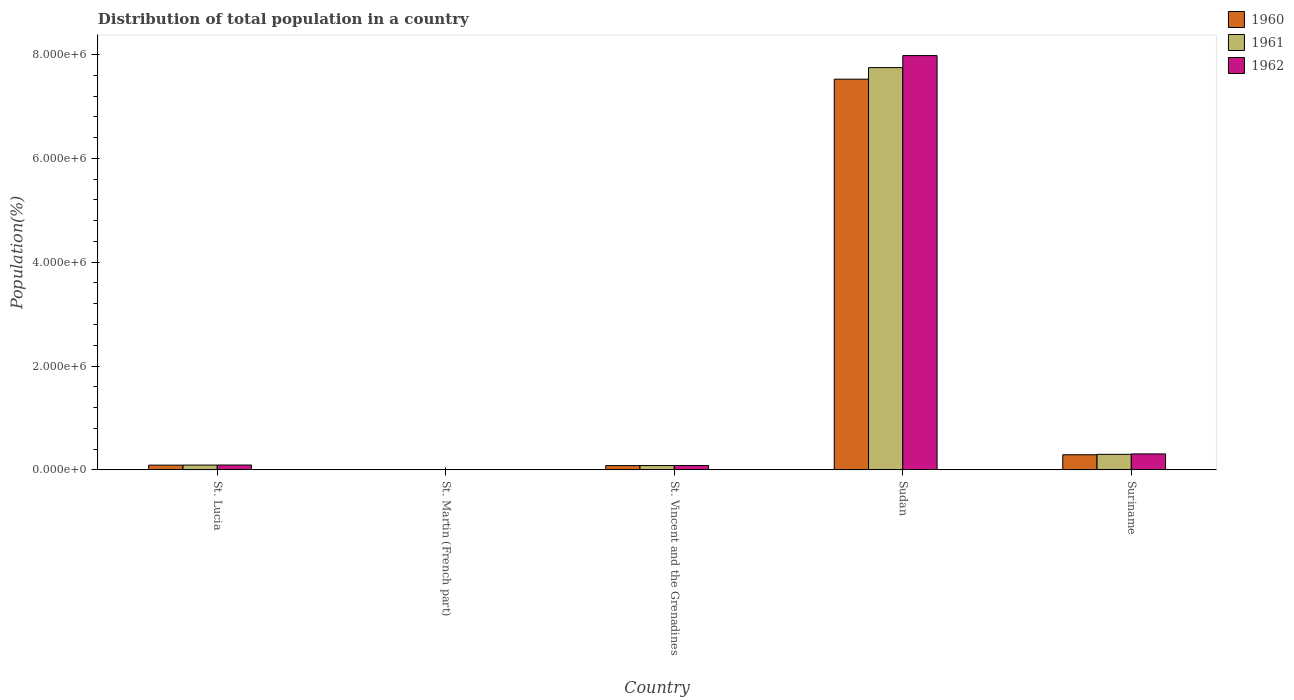How many different coloured bars are there?
Offer a very short reply. 3. How many groups of bars are there?
Offer a very short reply. 5. Are the number of bars on each tick of the X-axis equal?
Offer a very short reply. Yes. What is the label of the 2nd group of bars from the left?
Keep it short and to the point. St. Martin (French part). What is the population of in 1962 in Sudan?
Provide a succinct answer. 7.98e+06. Across all countries, what is the maximum population of in 1961?
Provide a short and direct response. 7.75e+06. Across all countries, what is the minimum population of in 1962?
Keep it short and to the point. 4566. In which country was the population of in 1961 maximum?
Your answer should be very brief. Sudan. In which country was the population of in 1960 minimum?
Offer a very short reply. St. Martin (French part). What is the total population of in 1962 in the graph?
Provide a short and direct response. 8.47e+06. What is the difference between the population of in 1960 in St. Martin (French part) and that in Suriname?
Ensure brevity in your answer.  -2.86e+05. What is the difference between the population of in 1961 in St. Lucia and the population of in 1960 in Sudan?
Make the answer very short. -7.44e+06. What is the average population of in 1962 per country?
Ensure brevity in your answer.  1.69e+06. What is the difference between the population of of/in 1960 and population of of/in 1962 in Suriname?
Offer a terse response. -1.64e+04. In how many countries, is the population of in 1962 greater than 7200000 %?
Your response must be concise. 1. What is the ratio of the population of in 1960 in St. Vincent and the Grenadines to that in Sudan?
Your response must be concise. 0.01. Is the difference between the population of in 1960 in St. Lucia and St. Vincent and the Grenadines greater than the difference between the population of in 1962 in St. Lucia and St. Vincent and the Grenadines?
Give a very brief answer. Yes. What is the difference between the highest and the second highest population of in 1960?
Offer a terse response. 7.24e+06. What is the difference between the highest and the lowest population of in 1962?
Your answer should be very brief. 7.98e+06. In how many countries, is the population of in 1961 greater than the average population of in 1961 taken over all countries?
Provide a short and direct response. 1. What does the 2nd bar from the right in St. Vincent and the Grenadines represents?
Give a very brief answer. 1961. How many bars are there?
Give a very brief answer. 15. Are all the bars in the graph horizontal?
Your answer should be compact. No. Are the values on the major ticks of Y-axis written in scientific E-notation?
Your answer should be compact. Yes. Does the graph contain any zero values?
Keep it short and to the point. No. Where does the legend appear in the graph?
Provide a short and direct response. Top right. How are the legend labels stacked?
Offer a terse response. Vertical. What is the title of the graph?
Give a very brief answer. Distribution of total population in a country. What is the label or title of the X-axis?
Ensure brevity in your answer.  Country. What is the label or title of the Y-axis?
Your answer should be compact. Population(%). What is the Population(%) of 1960 in St. Lucia?
Give a very brief answer. 8.99e+04. What is the Population(%) in 1961 in St. Lucia?
Give a very brief answer. 9.09e+04. What is the Population(%) in 1962 in St. Lucia?
Offer a very short reply. 9.21e+04. What is the Population(%) in 1960 in St. Martin (French part)?
Offer a terse response. 4279. What is the Population(%) in 1961 in St. Martin (French part)?
Keep it short and to the point. 4453. What is the Population(%) in 1962 in St. Martin (French part)?
Ensure brevity in your answer.  4566. What is the Population(%) in 1960 in St. Vincent and the Grenadines?
Offer a terse response. 8.09e+04. What is the Population(%) in 1961 in St. Vincent and the Grenadines?
Your answer should be very brief. 8.21e+04. What is the Population(%) of 1962 in St. Vincent and the Grenadines?
Ensure brevity in your answer.  8.32e+04. What is the Population(%) in 1960 in Sudan?
Provide a succinct answer. 7.53e+06. What is the Population(%) in 1961 in Sudan?
Offer a very short reply. 7.75e+06. What is the Population(%) of 1962 in Sudan?
Make the answer very short. 7.98e+06. What is the Population(%) of 1960 in Suriname?
Your answer should be compact. 2.90e+05. What is the Population(%) in 1961 in Suriname?
Your answer should be very brief. 2.98e+05. What is the Population(%) of 1962 in Suriname?
Provide a succinct answer. 3.06e+05. Across all countries, what is the maximum Population(%) in 1960?
Your response must be concise. 7.53e+06. Across all countries, what is the maximum Population(%) in 1961?
Your answer should be compact. 7.75e+06. Across all countries, what is the maximum Population(%) of 1962?
Your response must be concise. 7.98e+06. Across all countries, what is the minimum Population(%) in 1960?
Your answer should be compact. 4279. Across all countries, what is the minimum Population(%) of 1961?
Offer a terse response. 4453. Across all countries, what is the minimum Population(%) in 1962?
Make the answer very short. 4566. What is the total Population(%) of 1960 in the graph?
Keep it short and to the point. 7.99e+06. What is the total Population(%) in 1961 in the graph?
Give a very brief answer. 8.23e+06. What is the total Population(%) in 1962 in the graph?
Offer a terse response. 8.47e+06. What is the difference between the Population(%) in 1960 in St. Lucia and that in St. Martin (French part)?
Offer a very short reply. 8.56e+04. What is the difference between the Population(%) in 1961 in St. Lucia and that in St. Martin (French part)?
Your response must be concise. 8.65e+04. What is the difference between the Population(%) in 1962 in St. Lucia and that in St. Martin (French part)?
Ensure brevity in your answer.  8.75e+04. What is the difference between the Population(%) of 1960 in St. Lucia and that in St. Vincent and the Grenadines?
Your answer should be compact. 8953. What is the difference between the Population(%) in 1961 in St. Lucia and that in St. Vincent and the Grenadines?
Give a very brief answer. 8769. What is the difference between the Population(%) in 1962 in St. Lucia and that in St. Vincent and the Grenadines?
Your response must be concise. 8880. What is the difference between the Population(%) in 1960 in St. Lucia and that in Sudan?
Provide a short and direct response. -7.44e+06. What is the difference between the Population(%) of 1961 in St. Lucia and that in Sudan?
Offer a very short reply. -7.66e+06. What is the difference between the Population(%) of 1962 in St. Lucia and that in Sudan?
Your response must be concise. -7.89e+06. What is the difference between the Population(%) of 1960 in St. Lucia and that in Suriname?
Your response must be concise. -2.00e+05. What is the difference between the Population(%) in 1961 in St. Lucia and that in Suriname?
Your answer should be very brief. -2.07e+05. What is the difference between the Population(%) of 1962 in St. Lucia and that in Suriname?
Offer a terse response. -2.14e+05. What is the difference between the Population(%) in 1960 in St. Martin (French part) and that in St. Vincent and the Grenadines?
Provide a short and direct response. -7.67e+04. What is the difference between the Population(%) of 1961 in St. Martin (French part) and that in St. Vincent and the Grenadines?
Offer a very short reply. -7.77e+04. What is the difference between the Population(%) of 1962 in St. Martin (French part) and that in St. Vincent and the Grenadines?
Provide a short and direct response. -7.86e+04. What is the difference between the Population(%) in 1960 in St. Martin (French part) and that in Sudan?
Offer a terse response. -7.52e+06. What is the difference between the Population(%) of 1961 in St. Martin (French part) and that in Sudan?
Make the answer very short. -7.75e+06. What is the difference between the Population(%) of 1962 in St. Martin (French part) and that in Sudan?
Your response must be concise. -7.98e+06. What is the difference between the Population(%) in 1960 in St. Martin (French part) and that in Suriname?
Make the answer very short. -2.86e+05. What is the difference between the Population(%) in 1961 in St. Martin (French part) and that in Suriname?
Your answer should be compact. -2.94e+05. What is the difference between the Population(%) in 1962 in St. Martin (French part) and that in Suriname?
Your answer should be very brief. -3.02e+05. What is the difference between the Population(%) of 1960 in St. Vincent and the Grenadines and that in Sudan?
Your answer should be compact. -7.45e+06. What is the difference between the Population(%) in 1961 in St. Vincent and the Grenadines and that in Sudan?
Offer a terse response. -7.67e+06. What is the difference between the Population(%) in 1962 in St. Vincent and the Grenadines and that in Sudan?
Provide a succinct answer. -7.90e+06. What is the difference between the Population(%) in 1960 in St. Vincent and the Grenadines and that in Suriname?
Give a very brief answer. -2.09e+05. What is the difference between the Population(%) of 1961 in St. Vincent and the Grenadines and that in Suriname?
Ensure brevity in your answer.  -2.16e+05. What is the difference between the Population(%) of 1962 in St. Vincent and the Grenadines and that in Suriname?
Give a very brief answer. -2.23e+05. What is the difference between the Population(%) of 1960 in Sudan and that in Suriname?
Provide a short and direct response. 7.24e+06. What is the difference between the Population(%) of 1961 in Sudan and that in Suriname?
Offer a terse response. 7.45e+06. What is the difference between the Population(%) of 1962 in Sudan and that in Suriname?
Your answer should be very brief. 7.68e+06. What is the difference between the Population(%) of 1960 in St. Lucia and the Population(%) of 1961 in St. Martin (French part)?
Give a very brief answer. 8.54e+04. What is the difference between the Population(%) in 1960 in St. Lucia and the Population(%) in 1962 in St. Martin (French part)?
Your answer should be compact. 8.53e+04. What is the difference between the Population(%) in 1961 in St. Lucia and the Population(%) in 1962 in St. Martin (French part)?
Provide a succinct answer. 8.63e+04. What is the difference between the Population(%) of 1960 in St. Lucia and the Population(%) of 1961 in St. Vincent and the Grenadines?
Keep it short and to the point. 7757. What is the difference between the Population(%) of 1960 in St. Lucia and the Population(%) of 1962 in St. Vincent and the Grenadines?
Offer a terse response. 6695. What is the difference between the Population(%) of 1961 in St. Lucia and the Population(%) of 1962 in St. Vincent and the Grenadines?
Offer a terse response. 7707. What is the difference between the Population(%) of 1960 in St. Lucia and the Population(%) of 1961 in Sudan?
Offer a terse response. -7.66e+06. What is the difference between the Population(%) in 1960 in St. Lucia and the Population(%) in 1962 in Sudan?
Offer a terse response. -7.89e+06. What is the difference between the Population(%) in 1961 in St. Lucia and the Population(%) in 1962 in Sudan?
Your response must be concise. -7.89e+06. What is the difference between the Population(%) of 1960 in St. Lucia and the Population(%) of 1961 in Suriname?
Keep it short and to the point. -2.08e+05. What is the difference between the Population(%) of 1960 in St. Lucia and the Population(%) of 1962 in Suriname?
Your answer should be very brief. -2.16e+05. What is the difference between the Population(%) of 1961 in St. Lucia and the Population(%) of 1962 in Suriname?
Ensure brevity in your answer.  -2.15e+05. What is the difference between the Population(%) of 1960 in St. Martin (French part) and the Population(%) of 1961 in St. Vincent and the Grenadines?
Your answer should be compact. -7.79e+04. What is the difference between the Population(%) of 1960 in St. Martin (French part) and the Population(%) of 1962 in St. Vincent and the Grenadines?
Make the answer very short. -7.89e+04. What is the difference between the Population(%) in 1961 in St. Martin (French part) and the Population(%) in 1962 in St. Vincent and the Grenadines?
Your answer should be compact. -7.88e+04. What is the difference between the Population(%) of 1960 in St. Martin (French part) and the Population(%) of 1961 in Sudan?
Provide a short and direct response. -7.75e+06. What is the difference between the Population(%) in 1960 in St. Martin (French part) and the Population(%) in 1962 in Sudan?
Ensure brevity in your answer.  -7.98e+06. What is the difference between the Population(%) of 1961 in St. Martin (French part) and the Population(%) of 1962 in Sudan?
Your response must be concise. -7.98e+06. What is the difference between the Population(%) in 1960 in St. Martin (French part) and the Population(%) in 1961 in Suriname?
Offer a terse response. -2.94e+05. What is the difference between the Population(%) of 1960 in St. Martin (French part) and the Population(%) of 1962 in Suriname?
Make the answer very short. -3.02e+05. What is the difference between the Population(%) of 1961 in St. Martin (French part) and the Population(%) of 1962 in Suriname?
Ensure brevity in your answer.  -3.02e+05. What is the difference between the Population(%) of 1960 in St. Vincent and the Grenadines and the Population(%) of 1961 in Sudan?
Ensure brevity in your answer.  -7.67e+06. What is the difference between the Population(%) in 1960 in St. Vincent and the Grenadines and the Population(%) in 1962 in Sudan?
Keep it short and to the point. -7.90e+06. What is the difference between the Population(%) of 1961 in St. Vincent and the Grenadines and the Population(%) of 1962 in Sudan?
Provide a short and direct response. -7.90e+06. What is the difference between the Population(%) of 1960 in St. Vincent and the Grenadines and the Population(%) of 1961 in Suriname?
Give a very brief answer. -2.17e+05. What is the difference between the Population(%) in 1960 in St. Vincent and the Grenadines and the Population(%) in 1962 in Suriname?
Your answer should be compact. -2.25e+05. What is the difference between the Population(%) of 1961 in St. Vincent and the Grenadines and the Population(%) of 1962 in Suriname?
Keep it short and to the point. -2.24e+05. What is the difference between the Population(%) in 1960 in Sudan and the Population(%) in 1961 in Suriname?
Ensure brevity in your answer.  7.23e+06. What is the difference between the Population(%) of 1960 in Sudan and the Population(%) of 1962 in Suriname?
Ensure brevity in your answer.  7.22e+06. What is the difference between the Population(%) in 1961 in Sudan and the Population(%) in 1962 in Suriname?
Ensure brevity in your answer.  7.44e+06. What is the average Population(%) of 1960 per country?
Make the answer very short. 1.60e+06. What is the average Population(%) of 1961 per country?
Provide a short and direct response. 1.65e+06. What is the average Population(%) in 1962 per country?
Keep it short and to the point. 1.69e+06. What is the difference between the Population(%) of 1960 and Population(%) of 1961 in St. Lucia?
Your response must be concise. -1012. What is the difference between the Population(%) in 1960 and Population(%) in 1962 in St. Lucia?
Keep it short and to the point. -2185. What is the difference between the Population(%) of 1961 and Population(%) of 1962 in St. Lucia?
Give a very brief answer. -1173. What is the difference between the Population(%) of 1960 and Population(%) of 1961 in St. Martin (French part)?
Offer a terse response. -174. What is the difference between the Population(%) in 1960 and Population(%) in 1962 in St. Martin (French part)?
Offer a very short reply. -287. What is the difference between the Population(%) in 1961 and Population(%) in 1962 in St. Martin (French part)?
Ensure brevity in your answer.  -113. What is the difference between the Population(%) in 1960 and Population(%) in 1961 in St. Vincent and the Grenadines?
Give a very brief answer. -1196. What is the difference between the Population(%) of 1960 and Population(%) of 1962 in St. Vincent and the Grenadines?
Offer a terse response. -2258. What is the difference between the Population(%) in 1961 and Population(%) in 1962 in St. Vincent and the Grenadines?
Your answer should be compact. -1062. What is the difference between the Population(%) of 1960 and Population(%) of 1961 in Sudan?
Give a very brief answer. -2.22e+05. What is the difference between the Population(%) of 1960 and Population(%) of 1962 in Sudan?
Your response must be concise. -4.54e+05. What is the difference between the Population(%) of 1961 and Population(%) of 1962 in Sudan?
Your answer should be compact. -2.32e+05. What is the difference between the Population(%) in 1960 and Population(%) in 1961 in Suriname?
Give a very brief answer. -8218. What is the difference between the Population(%) in 1960 and Population(%) in 1962 in Suriname?
Ensure brevity in your answer.  -1.64e+04. What is the difference between the Population(%) of 1961 and Population(%) of 1962 in Suriname?
Offer a very short reply. -8140. What is the ratio of the Population(%) of 1960 in St. Lucia to that in St. Martin (French part)?
Give a very brief answer. 21.01. What is the ratio of the Population(%) in 1961 in St. Lucia to that in St. Martin (French part)?
Keep it short and to the point. 20.42. What is the ratio of the Population(%) of 1962 in St. Lucia to that in St. Martin (French part)?
Keep it short and to the point. 20.17. What is the ratio of the Population(%) of 1960 in St. Lucia to that in St. Vincent and the Grenadines?
Ensure brevity in your answer.  1.11. What is the ratio of the Population(%) of 1961 in St. Lucia to that in St. Vincent and the Grenadines?
Your response must be concise. 1.11. What is the ratio of the Population(%) of 1962 in St. Lucia to that in St. Vincent and the Grenadines?
Offer a terse response. 1.11. What is the ratio of the Population(%) in 1960 in St. Lucia to that in Sudan?
Your answer should be compact. 0.01. What is the ratio of the Population(%) in 1961 in St. Lucia to that in Sudan?
Keep it short and to the point. 0.01. What is the ratio of the Population(%) in 1962 in St. Lucia to that in Sudan?
Offer a terse response. 0.01. What is the ratio of the Population(%) of 1960 in St. Lucia to that in Suriname?
Provide a short and direct response. 0.31. What is the ratio of the Population(%) of 1961 in St. Lucia to that in Suriname?
Your answer should be very brief. 0.3. What is the ratio of the Population(%) of 1962 in St. Lucia to that in Suriname?
Keep it short and to the point. 0.3. What is the ratio of the Population(%) of 1960 in St. Martin (French part) to that in St. Vincent and the Grenadines?
Keep it short and to the point. 0.05. What is the ratio of the Population(%) of 1961 in St. Martin (French part) to that in St. Vincent and the Grenadines?
Offer a terse response. 0.05. What is the ratio of the Population(%) in 1962 in St. Martin (French part) to that in St. Vincent and the Grenadines?
Provide a succinct answer. 0.05. What is the ratio of the Population(%) in 1960 in St. Martin (French part) to that in Sudan?
Ensure brevity in your answer.  0. What is the ratio of the Population(%) in 1961 in St. Martin (French part) to that in Sudan?
Your response must be concise. 0. What is the ratio of the Population(%) in 1962 in St. Martin (French part) to that in Sudan?
Your answer should be very brief. 0. What is the ratio of the Population(%) of 1960 in St. Martin (French part) to that in Suriname?
Ensure brevity in your answer.  0.01. What is the ratio of the Population(%) in 1961 in St. Martin (French part) to that in Suriname?
Your response must be concise. 0.01. What is the ratio of the Population(%) of 1962 in St. Martin (French part) to that in Suriname?
Provide a short and direct response. 0.01. What is the ratio of the Population(%) of 1960 in St. Vincent and the Grenadines to that in Sudan?
Ensure brevity in your answer.  0.01. What is the ratio of the Population(%) of 1961 in St. Vincent and the Grenadines to that in Sudan?
Ensure brevity in your answer.  0.01. What is the ratio of the Population(%) in 1962 in St. Vincent and the Grenadines to that in Sudan?
Make the answer very short. 0.01. What is the ratio of the Population(%) of 1960 in St. Vincent and the Grenadines to that in Suriname?
Keep it short and to the point. 0.28. What is the ratio of the Population(%) of 1961 in St. Vincent and the Grenadines to that in Suriname?
Offer a very short reply. 0.28. What is the ratio of the Population(%) in 1962 in St. Vincent and the Grenadines to that in Suriname?
Make the answer very short. 0.27. What is the ratio of the Population(%) in 1960 in Sudan to that in Suriname?
Provide a succinct answer. 25.96. What is the ratio of the Population(%) of 1961 in Sudan to that in Suriname?
Ensure brevity in your answer.  25.99. What is the ratio of the Population(%) in 1962 in Sudan to that in Suriname?
Your answer should be compact. 26.06. What is the difference between the highest and the second highest Population(%) in 1960?
Ensure brevity in your answer.  7.24e+06. What is the difference between the highest and the second highest Population(%) in 1961?
Your answer should be compact. 7.45e+06. What is the difference between the highest and the second highest Population(%) of 1962?
Provide a succinct answer. 7.68e+06. What is the difference between the highest and the lowest Population(%) of 1960?
Offer a terse response. 7.52e+06. What is the difference between the highest and the lowest Population(%) in 1961?
Offer a very short reply. 7.75e+06. What is the difference between the highest and the lowest Population(%) of 1962?
Ensure brevity in your answer.  7.98e+06. 